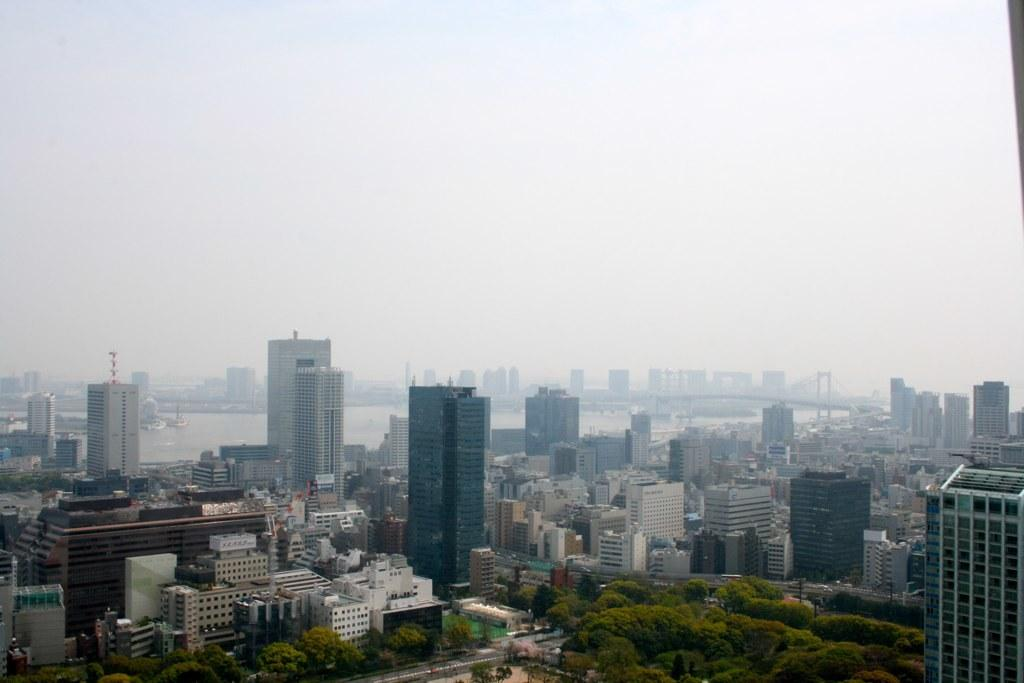What is located in the center of the image? There are buildings in the center of the image. What type of vegetation can be seen at the bottom side of the image? There are trees at the bottom side of the image. What type of sign can be seen hanging from the trees in the image? There is no sign present in the image; it only features buildings and trees. Is there a scarecrow visible among the trees in the image? There is no scarecrow present in the image; it only features buildings and trees. 